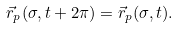<formula> <loc_0><loc_0><loc_500><loc_500>\vec { r } _ { p } ( \sigma , t + 2 \pi ) = \vec { r } _ { p } ( \sigma , t ) .</formula> 